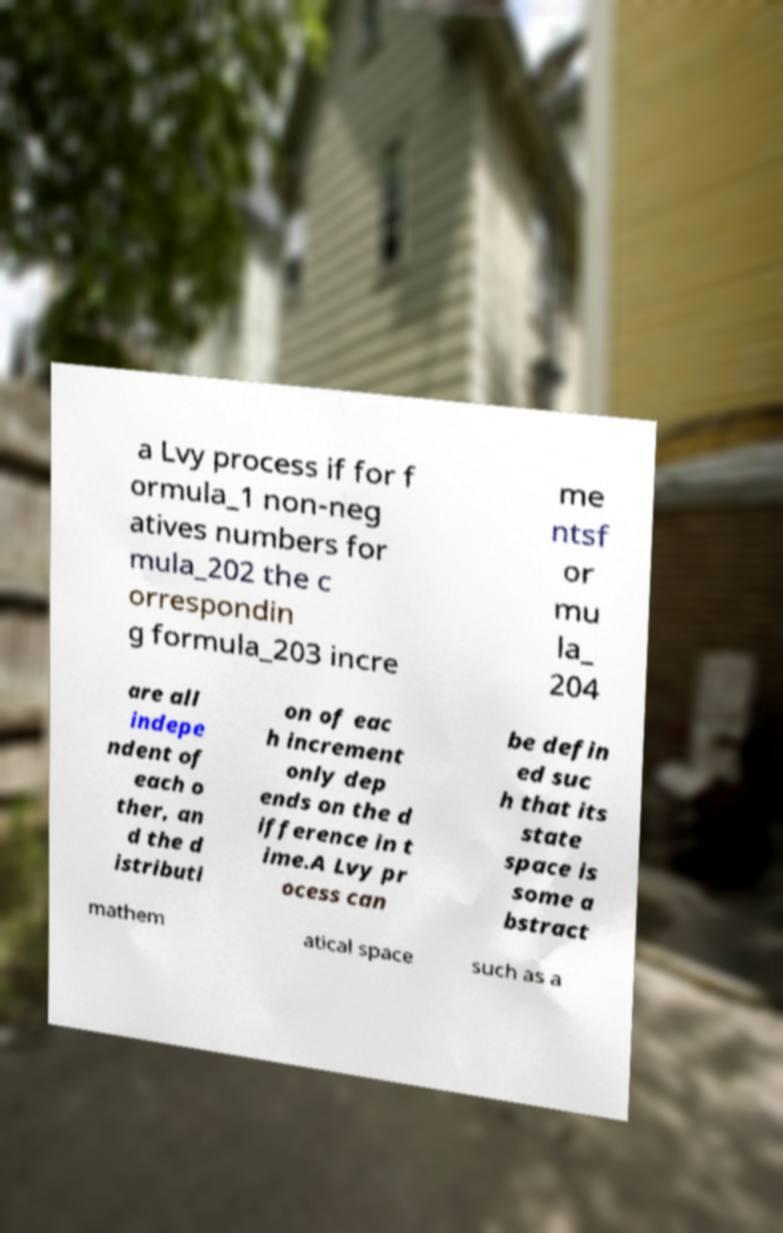For documentation purposes, I need the text within this image transcribed. Could you provide that? a Lvy process if for f ormula_1 non-neg atives numbers for mula_202 the c orrespondin g formula_203 incre me ntsf or mu la_ 204 are all indepe ndent of each o ther, an d the d istributi on of eac h increment only dep ends on the d ifference in t ime.A Lvy pr ocess can be defin ed suc h that its state space is some a bstract mathem atical space such as a 